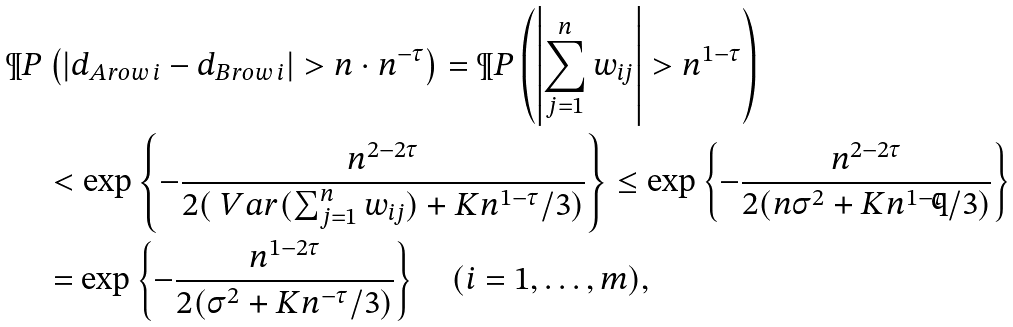<formula> <loc_0><loc_0><loc_500><loc_500>\P P & \left ( | d _ { A r o w \, i } - d _ { B r o w \, i } | > n \cdot n ^ { - \tau } \right ) = \P P \left ( \left | \sum _ { j = 1 } ^ { n } w _ { i j } \right | > n ^ { 1 - \tau } \right ) \\ & < \exp \left \{ - \frac { n ^ { 2 - 2 \tau } } { 2 ( \ V a r ( \sum _ { j = 1 } ^ { n } w _ { i j } ) + K n ^ { 1 - \tau } / 3 ) } \right \} \leq \exp \left \{ - \frac { n ^ { 2 - 2 \tau } } { 2 ( n \sigma ^ { 2 } + K n ^ { 1 - \tau } / 3 ) } \right \} \\ & = \exp \left \{ - \frac { n ^ { 1 - 2 \tau } } { 2 ( \sigma ^ { 2 } + K n ^ { - \tau } / 3 ) } \right \} \quad ( i = 1 , \dots , m ) ,</formula> 